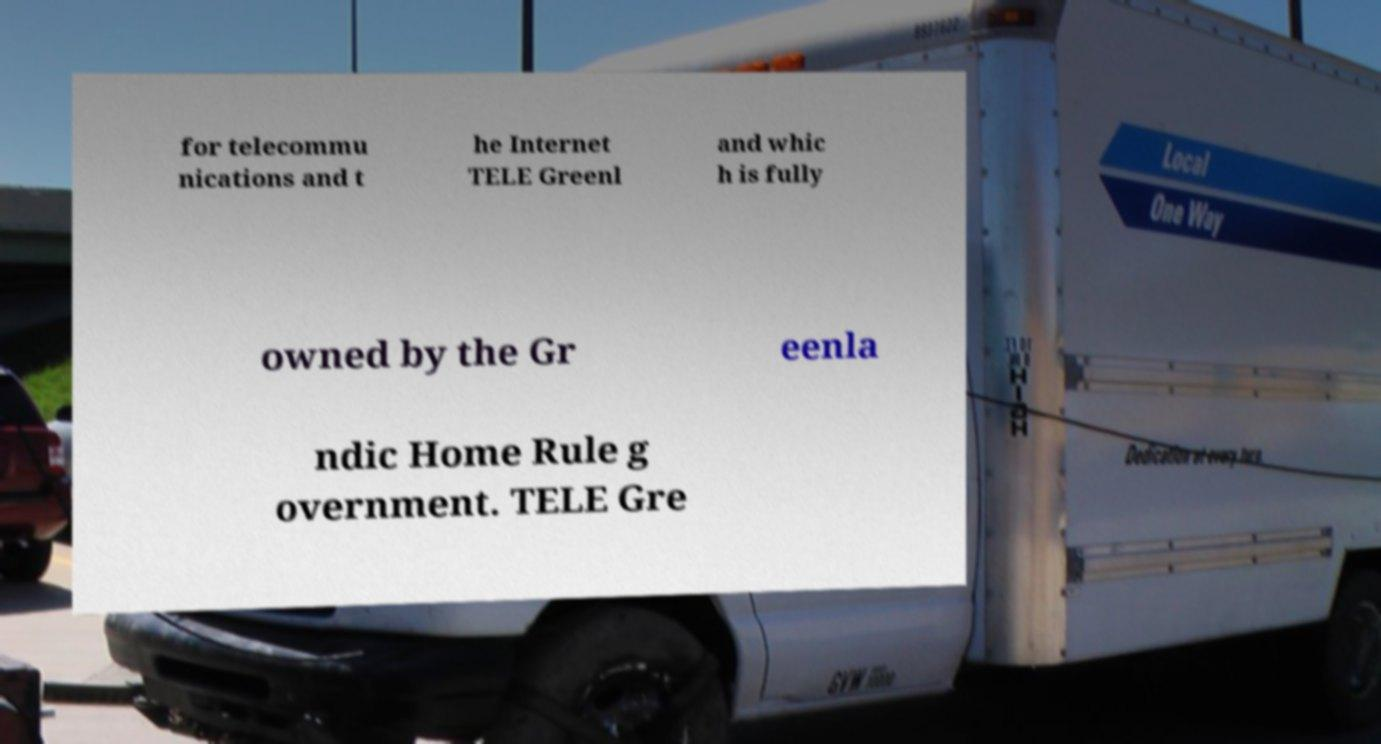For documentation purposes, I need the text within this image transcribed. Could you provide that? for telecommu nications and t he Internet TELE Greenl and whic h is fully owned by the Gr eenla ndic Home Rule g overnment. TELE Gre 